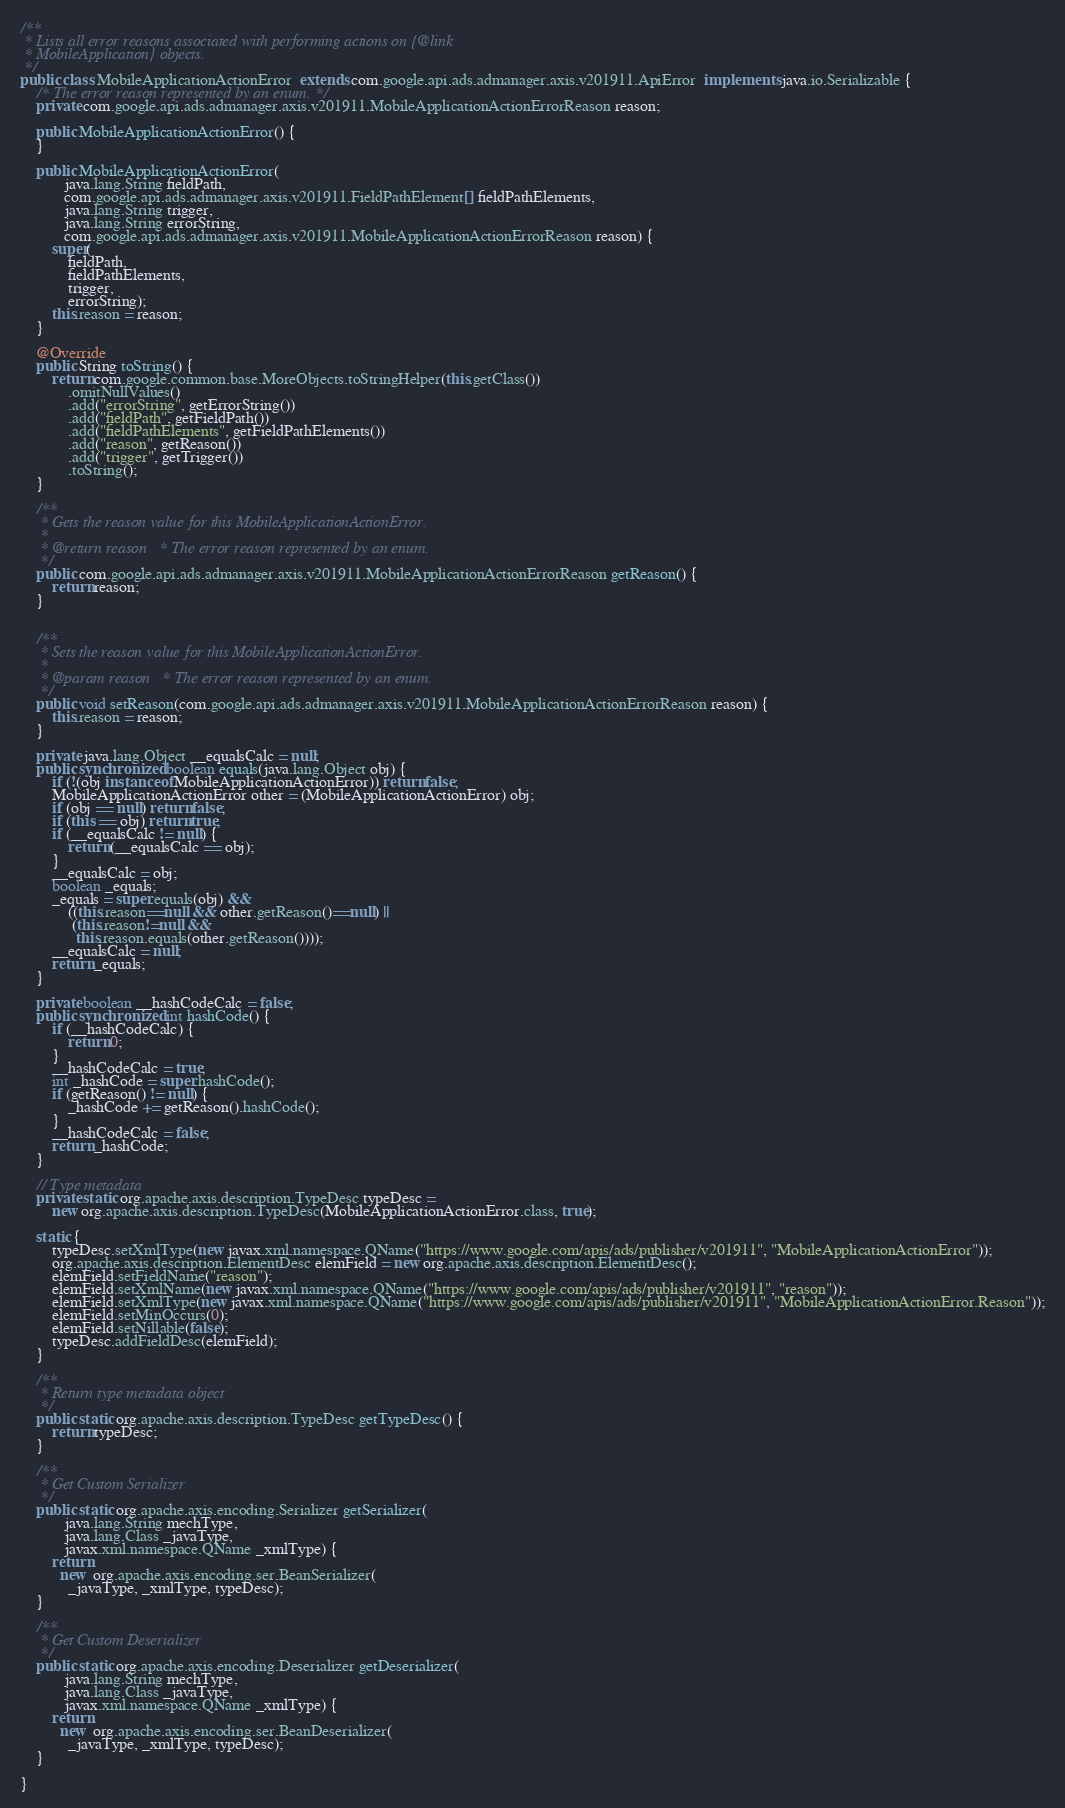Convert code to text. <code><loc_0><loc_0><loc_500><loc_500><_Java_>

/**
 * Lists all error reasons associated with performing actions on {@link
 * MobileApplication} objects.
 */
public class MobileApplicationActionError  extends com.google.api.ads.admanager.axis.v201911.ApiError  implements java.io.Serializable {
    /* The error reason represented by an enum. */
    private com.google.api.ads.admanager.axis.v201911.MobileApplicationActionErrorReason reason;

    public MobileApplicationActionError() {
    }

    public MobileApplicationActionError(
           java.lang.String fieldPath,
           com.google.api.ads.admanager.axis.v201911.FieldPathElement[] fieldPathElements,
           java.lang.String trigger,
           java.lang.String errorString,
           com.google.api.ads.admanager.axis.v201911.MobileApplicationActionErrorReason reason) {
        super(
            fieldPath,
            fieldPathElements,
            trigger,
            errorString);
        this.reason = reason;
    }

    @Override
    public String toString() {
        return com.google.common.base.MoreObjects.toStringHelper(this.getClass())
            .omitNullValues()
            .add("errorString", getErrorString())
            .add("fieldPath", getFieldPath())
            .add("fieldPathElements", getFieldPathElements())
            .add("reason", getReason())
            .add("trigger", getTrigger())
            .toString();
    }

    /**
     * Gets the reason value for this MobileApplicationActionError.
     * 
     * @return reason   * The error reason represented by an enum.
     */
    public com.google.api.ads.admanager.axis.v201911.MobileApplicationActionErrorReason getReason() {
        return reason;
    }


    /**
     * Sets the reason value for this MobileApplicationActionError.
     * 
     * @param reason   * The error reason represented by an enum.
     */
    public void setReason(com.google.api.ads.admanager.axis.v201911.MobileApplicationActionErrorReason reason) {
        this.reason = reason;
    }

    private java.lang.Object __equalsCalc = null;
    public synchronized boolean equals(java.lang.Object obj) {
        if (!(obj instanceof MobileApplicationActionError)) return false;
        MobileApplicationActionError other = (MobileApplicationActionError) obj;
        if (obj == null) return false;
        if (this == obj) return true;
        if (__equalsCalc != null) {
            return (__equalsCalc == obj);
        }
        __equalsCalc = obj;
        boolean _equals;
        _equals = super.equals(obj) && 
            ((this.reason==null && other.getReason()==null) || 
             (this.reason!=null &&
              this.reason.equals(other.getReason())));
        __equalsCalc = null;
        return _equals;
    }

    private boolean __hashCodeCalc = false;
    public synchronized int hashCode() {
        if (__hashCodeCalc) {
            return 0;
        }
        __hashCodeCalc = true;
        int _hashCode = super.hashCode();
        if (getReason() != null) {
            _hashCode += getReason().hashCode();
        }
        __hashCodeCalc = false;
        return _hashCode;
    }

    // Type metadata
    private static org.apache.axis.description.TypeDesc typeDesc =
        new org.apache.axis.description.TypeDesc(MobileApplicationActionError.class, true);

    static {
        typeDesc.setXmlType(new javax.xml.namespace.QName("https://www.google.com/apis/ads/publisher/v201911", "MobileApplicationActionError"));
        org.apache.axis.description.ElementDesc elemField = new org.apache.axis.description.ElementDesc();
        elemField.setFieldName("reason");
        elemField.setXmlName(new javax.xml.namespace.QName("https://www.google.com/apis/ads/publisher/v201911", "reason"));
        elemField.setXmlType(new javax.xml.namespace.QName("https://www.google.com/apis/ads/publisher/v201911", "MobileApplicationActionError.Reason"));
        elemField.setMinOccurs(0);
        elemField.setNillable(false);
        typeDesc.addFieldDesc(elemField);
    }

    /**
     * Return type metadata object
     */
    public static org.apache.axis.description.TypeDesc getTypeDesc() {
        return typeDesc;
    }

    /**
     * Get Custom Serializer
     */
    public static org.apache.axis.encoding.Serializer getSerializer(
           java.lang.String mechType, 
           java.lang.Class _javaType,  
           javax.xml.namespace.QName _xmlType) {
        return 
          new  org.apache.axis.encoding.ser.BeanSerializer(
            _javaType, _xmlType, typeDesc);
    }

    /**
     * Get Custom Deserializer
     */
    public static org.apache.axis.encoding.Deserializer getDeserializer(
           java.lang.String mechType, 
           java.lang.Class _javaType,  
           javax.xml.namespace.QName _xmlType) {
        return 
          new  org.apache.axis.encoding.ser.BeanDeserializer(
            _javaType, _xmlType, typeDesc);
    }

}
</code> 